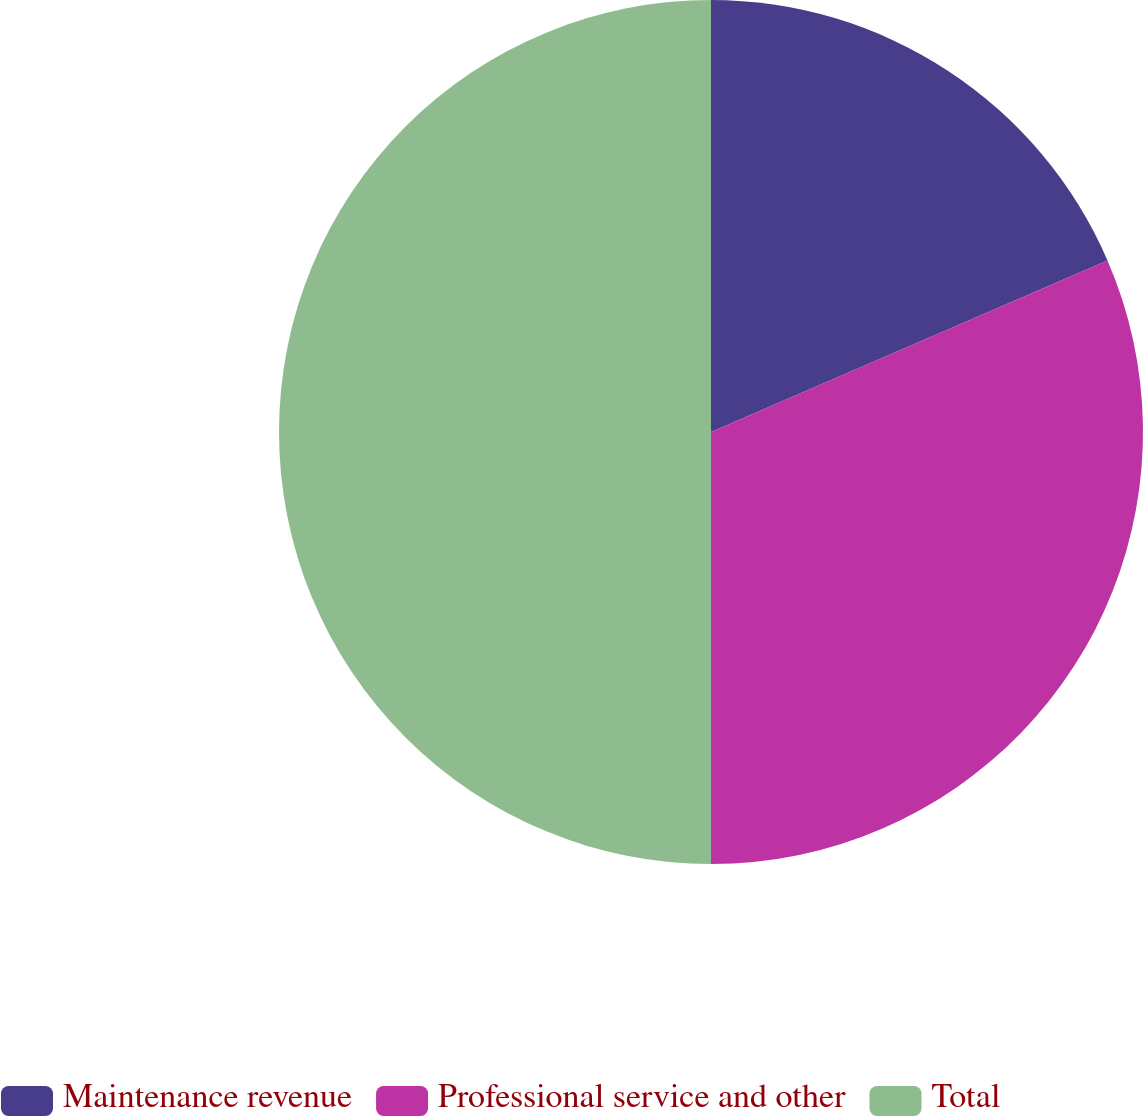<chart> <loc_0><loc_0><loc_500><loc_500><pie_chart><fcel>Maintenance revenue<fcel>Professional service and other<fcel>Total<nl><fcel>18.5%<fcel>31.5%<fcel>50.0%<nl></chart> 